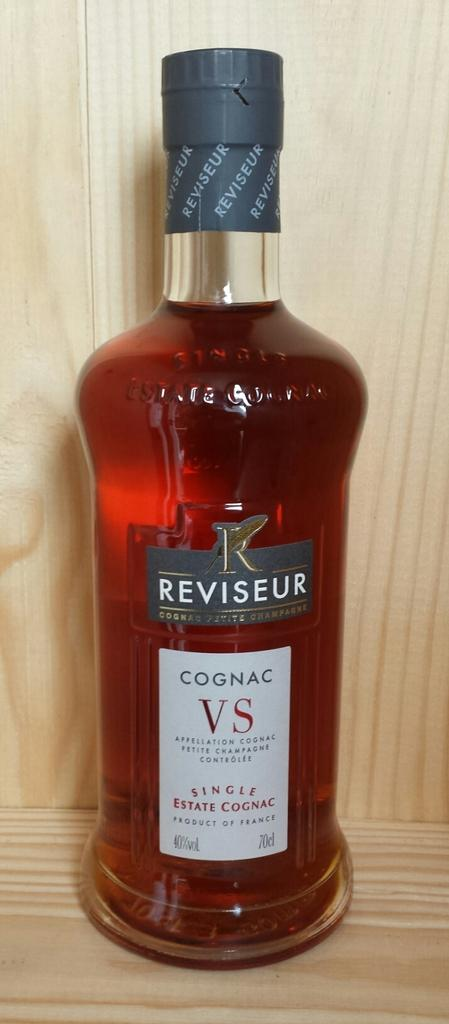Provide a one-sentence caption for the provided image. A full bottle of Reviseur Cognac VS Single Estate Cognag. 